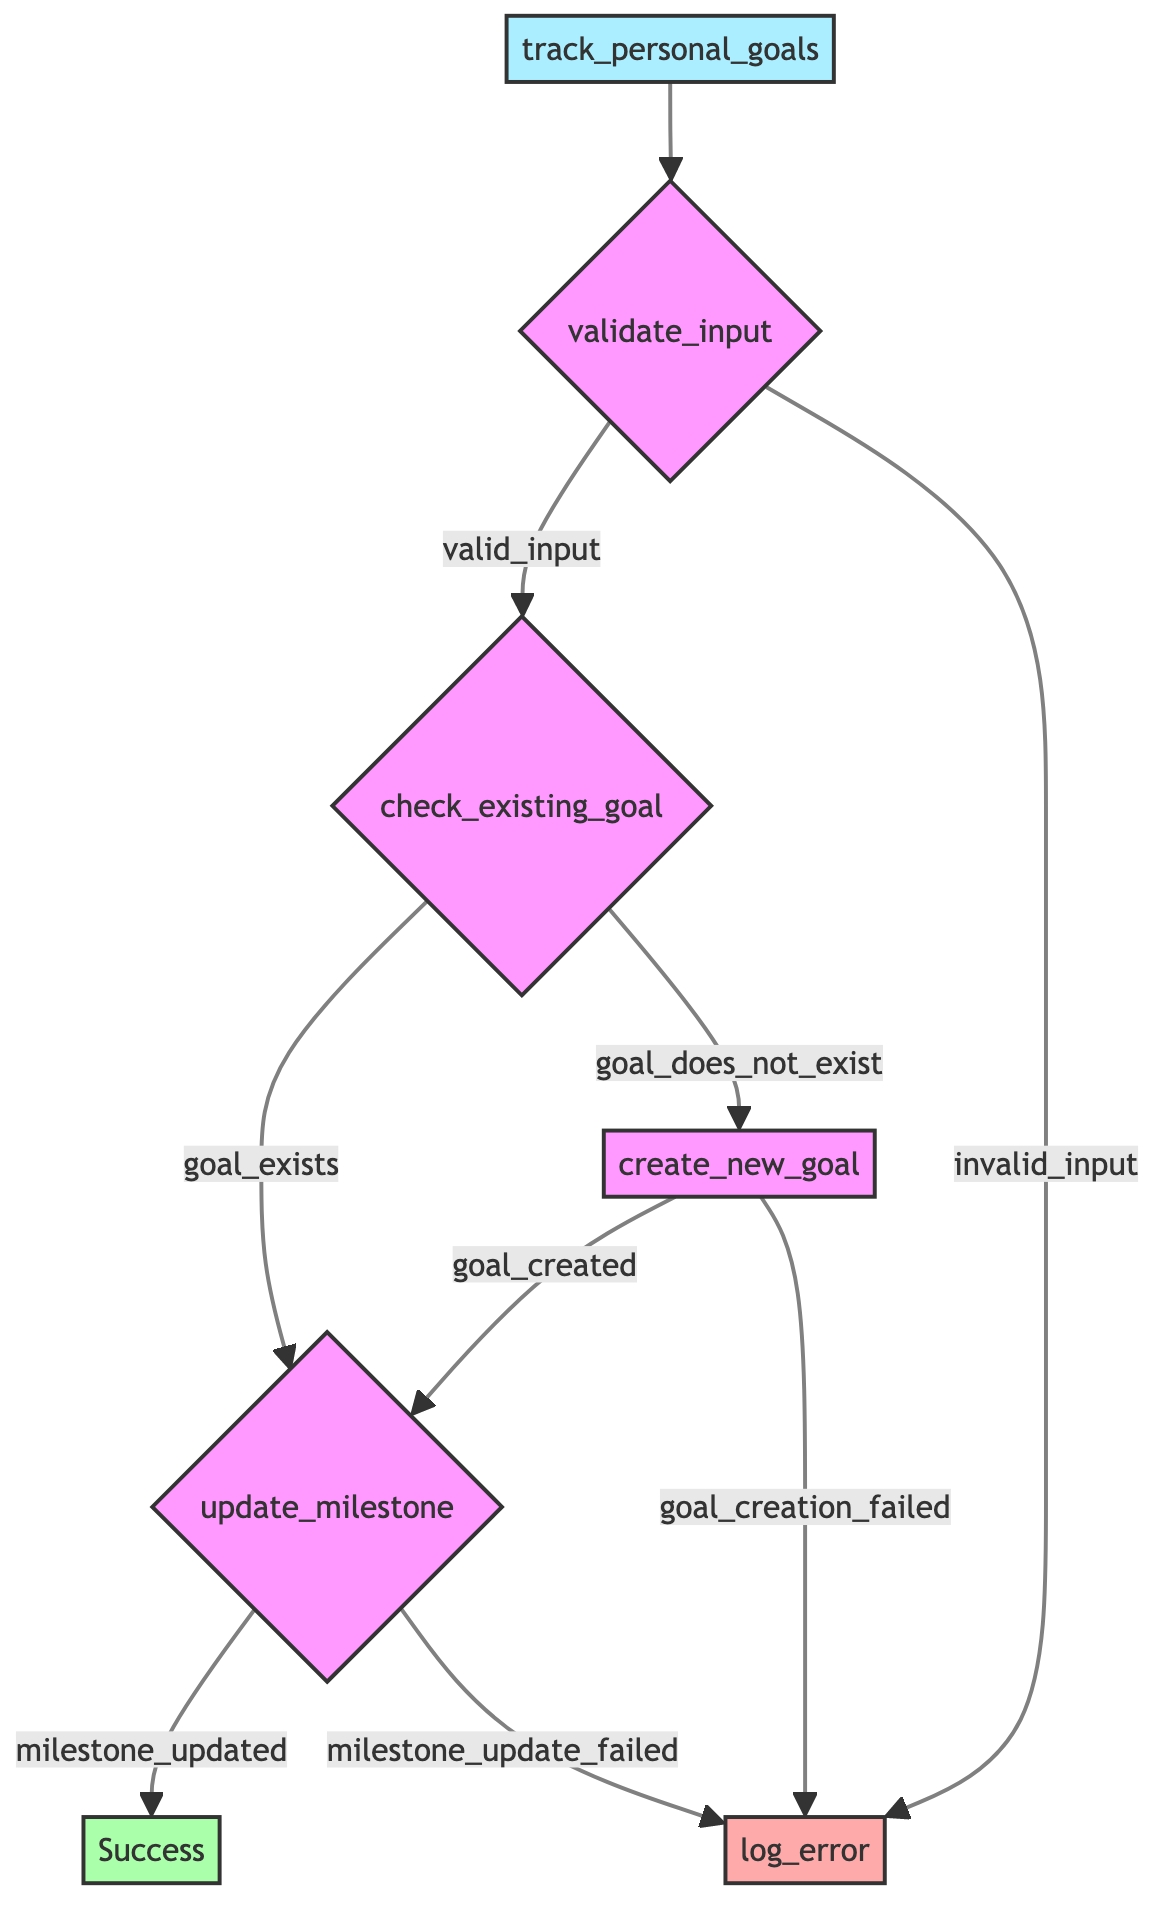What are the parameters of the function? The parameters of the function are listed just after the function's name, which include goal_name, milestone_name, and current_status.
Answer: goal_name, milestone_name, current_status How many main steps are there in the flowchart? Each main step in the flowchart represents a different operation within the function. By counting the steps, we find there are five steps: validate_input, check_existing_goal, create_new_goal, update_milestone, and log_error.
Answer: five What is the outcome if the input is invalid? In the flowchart, if the input is invalid, it moves to the step labeled log_error, meaning an error is logged for further action.
Answer: log_error What happens if the goal already exists? If the goal already exists, the flow proceeds to the step update_milestone, indicating that the existing goal will have a milestone added to it.
Answer: update_milestone What are the possible outcomes after creating a new goal? After creating a new goal, the outcomes are either goal_created or goal_creation_failed, which determines the next steps in the flowchart.
Answer: goal_created, goal_creation_failed What is the relation between updating the milestone and checking existing goals? The update_milestone step is conditional on whether the goal exists or if a new goal has been created, which means it directly depends on the outcomes of check_existing_goal and create_new_goal.
Answer: direct dependency How many error logging conditions are present in the flowchart? The flowchart specifies three conditions that can lead to error logging: invalid_input, goal_creation_failed, and milestone_update_failed, thus the total number is three.
Answer: three If a milestone update fails, what step is taken? If the milestone update fails, the flow proceeds to the step labeled log_error, which indicates that the function will log the failure for further action.
Answer: log_error What node indicates the successful completion of the function? The final step labeled Success in the flowchart indicates that the function has completed all operations successfully without any errors.
Answer: Success 